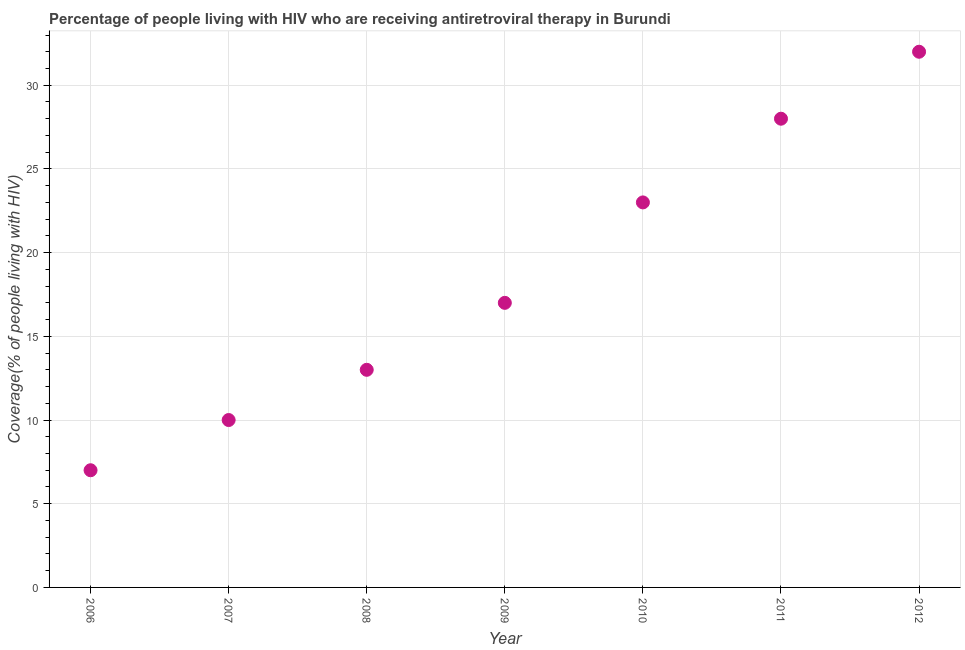What is the antiretroviral therapy coverage in 2010?
Your response must be concise. 23. Across all years, what is the maximum antiretroviral therapy coverage?
Provide a short and direct response. 32. Across all years, what is the minimum antiretroviral therapy coverage?
Keep it short and to the point. 7. In which year was the antiretroviral therapy coverage minimum?
Offer a very short reply. 2006. What is the sum of the antiretroviral therapy coverage?
Provide a short and direct response. 130. What is the difference between the antiretroviral therapy coverage in 2008 and 2012?
Keep it short and to the point. -19. What is the average antiretroviral therapy coverage per year?
Ensure brevity in your answer.  18.57. What is the median antiretroviral therapy coverage?
Make the answer very short. 17. What is the ratio of the antiretroviral therapy coverage in 2006 to that in 2009?
Your answer should be very brief. 0.41. Is the antiretroviral therapy coverage in 2009 less than that in 2010?
Give a very brief answer. Yes. Is the difference between the antiretroviral therapy coverage in 2006 and 2010 greater than the difference between any two years?
Make the answer very short. No. What is the difference between the highest and the second highest antiretroviral therapy coverage?
Offer a terse response. 4. What is the difference between the highest and the lowest antiretroviral therapy coverage?
Your response must be concise. 25. How many dotlines are there?
Make the answer very short. 1. Does the graph contain any zero values?
Your answer should be very brief. No. What is the title of the graph?
Provide a short and direct response. Percentage of people living with HIV who are receiving antiretroviral therapy in Burundi. What is the label or title of the X-axis?
Provide a short and direct response. Year. What is the label or title of the Y-axis?
Offer a terse response. Coverage(% of people living with HIV). What is the Coverage(% of people living with HIV) in 2007?
Keep it short and to the point. 10. What is the Coverage(% of people living with HIV) in 2009?
Your response must be concise. 17. What is the Coverage(% of people living with HIV) in 2010?
Provide a short and direct response. 23. What is the Coverage(% of people living with HIV) in 2011?
Give a very brief answer. 28. What is the difference between the Coverage(% of people living with HIV) in 2006 and 2007?
Offer a very short reply. -3. What is the difference between the Coverage(% of people living with HIV) in 2006 and 2009?
Ensure brevity in your answer.  -10. What is the difference between the Coverage(% of people living with HIV) in 2006 and 2010?
Offer a very short reply. -16. What is the difference between the Coverage(% of people living with HIV) in 2007 and 2008?
Provide a short and direct response. -3. What is the difference between the Coverage(% of people living with HIV) in 2007 and 2010?
Ensure brevity in your answer.  -13. What is the difference between the Coverage(% of people living with HIV) in 2008 and 2011?
Your answer should be compact. -15. What is the difference between the Coverage(% of people living with HIV) in 2009 and 2010?
Your answer should be compact. -6. What is the difference between the Coverage(% of people living with HIV) in 2009 and 2011?
Ensure brevity in your answer.  -11. What is the difference between the Coverage(% of people living with HIV) in 2010 and 2011?
Your answer should be compact. -5. What is the difference between the Coverage(% of people living with HIV) in 2010 and 2012?
Keep it short and to the point. -9. What is the ratio of the Coverage(% of people living with HIV) in 2006 to that in 2007?
Your answer should be compact. 0.7. What is the ratio of the Coverage(% of people living with HIV) in 2006 to that in 2008?
Provide a succinct answer. 0.54. What is the ratio of the Coverage(% of people living with HIV) in 2006 to that in 2009?
Give a very brief answer. 0.41. What is the ratio of the Coverage(% of people living with HIV) in 2006 to that in 2010?
Your answer should be compact. 0.3. What is the ratio of the Coverage(% of people living with HIV) in 2006 to that in 2012?
Provide a succinct answer. 0.22. What is the ratio of the Coverage(% of people living with HIV) in 2007 to that in 2008?
Your answer should be very brief. 0.77. What is the ratio of the Coverage(% of people living with HIV) in 2007 to that in 2009?
Your response must be concise. 0.59. What is the ratio of the Coverage(% of people living with HIV) in 2007 to that in 2010?
Ensure brevity in your answer.  0.43. What is the ratio of the Coverage(% of people living with HIV) in 2007 to that in 2011?
Your answer should be compact. 0.36. What is the ratio of the Coverage(% of people living with HIV) in 2007 to that in 2012?
Keep it short and to the point. 0.31. What is the ratio of the Coverage(% of people living with HIV) in 2008 to that in 2009?
Give a very brief answer. 0.77. What is the ratio of the Coverage(% of people living with HIV) in 2008 to that in 2010?
Your answer should be compact. 0.56. What is the ratio of the Coverage(% of people living with HIV) in 2008 to that in 2011?
Ensure brevity in your answer.  0.46. What is the ratio of the Coverage(% of people living with HIV) in 2008 to that in 2012?
Keep it short and to the point. 0.41. What is the ratio of the Coverage(% of people living with HIV) in 2009 to that in 2010?
Ensure brevity in your answer.  0.74. What is the ratio of the Coverage(% of people living with HIV) in 2009 to that in 2011?
Ensure brevity in your answer.  0.61. What is the ratio of the Coverage(% of people living with HIV) in 2009 to that in 2012?
Provide a succinct answer. 0.53. What is the ratio of the Coverage(% of people living with HIV) in 2010 to that in 2011?
Ensure brevity in your answer.  0.82. What is the ratio of the Coverage(% of people living with HIV) in 2010 to that in 2012?
Keep it short and to the point. 0.72. 